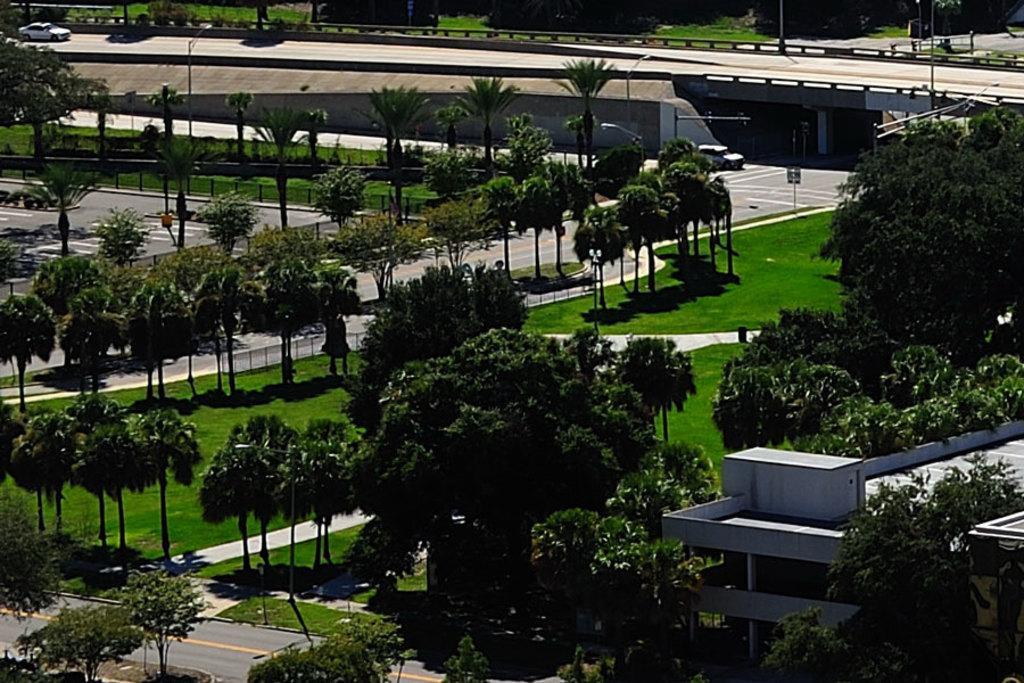Please provide a concise description of this image. In this image I can see trees and grass in green color, background I can see a building in white color, few vehicles on the road and I can also see few light poles and a bridge. 